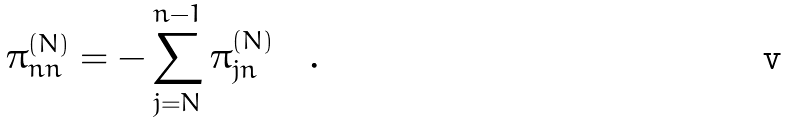<formula> <loc_0><loc_0><loc_500><loc_500>\pi ^ { ( N ) } _ { n n } = - \sum _ { j = N } ^ { n - 1 } \pi ^ { ( N ) } _ { j n } \quad .</formula> 